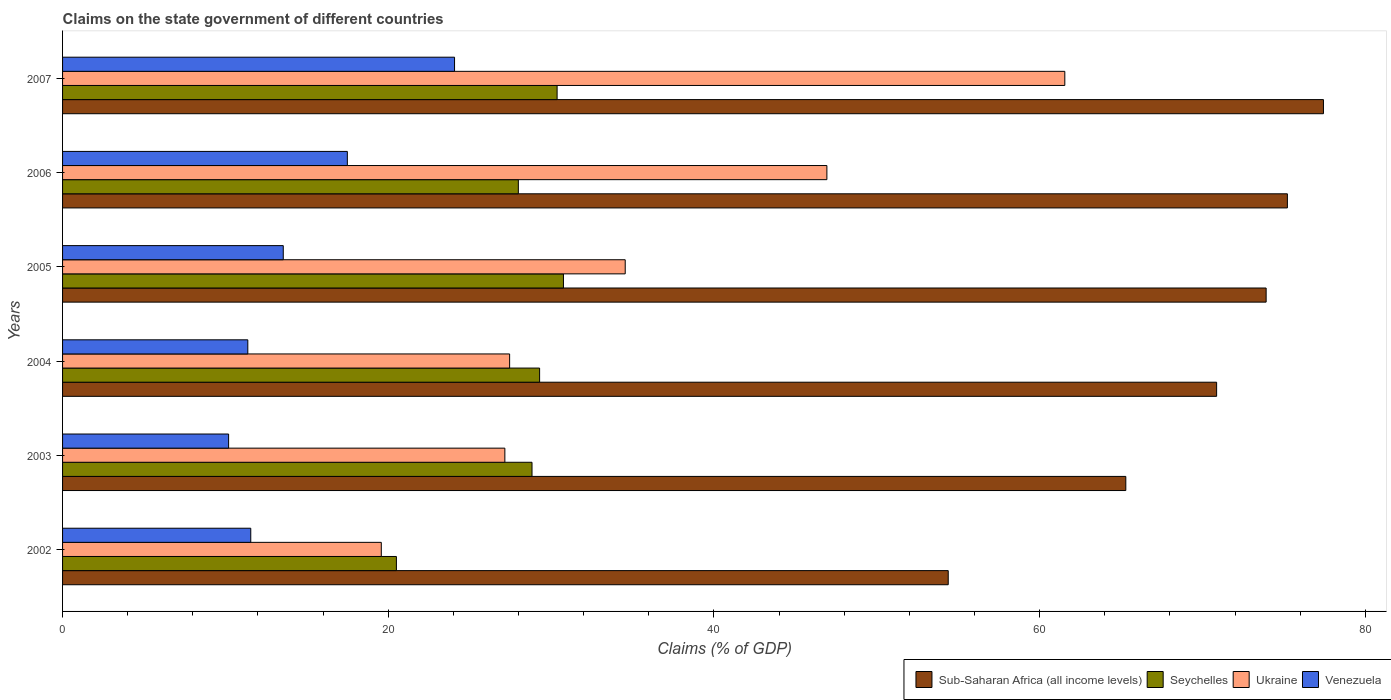How many groups of bars are there?
Ensure brevity in your answer.  6. Are the number of bars per tick equal to the number of legend labels?
Your answer should be compact. Yes. Are the number of bars on each tick of the Y-axis equal?
Give a very brief answer. Yes. How many bars are there on the 2nd tick from the top?
Give a very brief answer. 4. What is the percentage of GDP claimed on the state government in Ukraine in 2003?
Offer a terse response. 27.16. Across all years, what is the maximum percentage of GDP claimed on the state government in Ukraine?
Offer a terse response. 61.54. Across all years, what is the minimum percentage of GDP claimed on the state government in Seychelles?
Provide a short and direct response. 20.5. In which year was the percentage of GDP claimed on the state government in Ukraine maximum?
Keep it short and to the point. 2007. What is the total percentage of GDP claimed on the state government in Sub-Saharan Africa (all income levels) in the graph?
Your answer should be very brief. 417.08. What is the difference between the percentage of GDP claimed on the state government in Ukraine in 2004 and that in 2005?
Provide a short and direct response. -7.1. What is the difference between the percentage of GDP claimed on the state government in Venezuela in 2004 and the percentage of GDP claimed on the state government in Seychelles in 2007?
Your response must be concise. -18.99. What is the average percentage of GDP claimed on the state government in Ukraine per year?
Offer a very short reply. 36.2. In the year 2007, what is the difference between the percentage of GDP claimed on the state government in Sub-Saharan Africa (all income levels) and percentage of GDP claimed on the state government in Seychelles?
Ensure brevity in your answer.  47.06. In how many years, is the percentage of GDP claimed on the state government in Sub-Saharan Africa (all income levels) greater than 8 %?
Offer a terse response. 6. What is the ratio of the percentage of GDP claimed on the state government in Ukraine in 2003 to that in 2006?
Provide a succinct answer. 0.58. What is the difference between the highest and the second highest percentage of GDP claimed on the state government in Ukraine?
Offer a very short reply. 14.61. What is the difference between the highest and the lowest percentage of GDP claimed on the state government in Ukraine?
Provide a succinct answer. 41.97. In how many years, is the percentage of GDP claimed on the state government in Sub-Saharan Africa (all income levels) greater than the average percentage of GDP claimed on the state government in Sub-Saharan Africa (all income levels) taken over all years?
Offer a terse response. 4. Is the sum of the percentage of GDP claimed on the state government in Sub-Saharan Africa (all income levels) in 2005 and 2007 greater than the maximum percentage of GDP claimed on the state government in Venezuela across all years?
Provide a short and direct response. Yes. Is it the case that in every year, the sum of the percentage of GDP claimed on the state government in Seychelles and percentage of GDP claimed on the state government in Sub-Saharan Africa (all income levels) is greater than the sum of percentage of GDP claimed on the state government in Ukraine and percentage of GDP claimed on the state government in Venezuela?
Give a very brief answer. Yes. What does the 2nd bar from the top in 2004 represents?
Give a very brief answer. Ukraine. What does the 4th bar from the bottom in 2006 represents?
Your response must be concise. Venezuela. How many years are there in the graph?
Your answer should be very brief. 6. Does the graph contain grids?
Your answer should be compact. No. Where does the legend appear in the graph?
Your answer should be very brief. Bottom right. How are the legend labels stacked?
Provide a short and direct response. Horizontal. What is the title of the graph?
Give a very brief answer. Claims on the state government of different countries. Does "OECD members" appear as one of the legend labels in the graph?
Keep it short and to the point. No. What is the label or title of the X-axis?
Your answer should be compact. Claims (% of GDP). What is the Claims (% of GDP) in Sub-Saharan Africa (all income levels) in 2002?
Provide a succinct answer. 54.38. What is the Claims (% of GDP) in Seychelles in 2002?
Ensure brevity in your answer.  20.5. What is the Claims (% of GDP) in Ukraine in 2002?
Make the answer very short. 19.57. What is the Claims (% of GDP) in Venezuela in 2002?
Keep it short and to the point. 11.56. What is the Claims (% of GDP) in Sub-Saharan Africa (all income levels) in 2003?
Offer a very short reply. 65.29. What is the Claims (% of GDP) in Seychelles in 2003?
Ensure brevity in your answer.  28.83. What is the Claims (% of GDP) of Ukraine in 2003?
Offer a terse response. 27.16. What is the Claims (% of GDP) in Venezuela in 2003?
Your answer should be very brief. 10.2. What is the Claims (% of GDP) of Sub-Saharan Africa (all income levels) in 2004?
Your answer should be compact. 70.86. What is the Claims (% of GDP) of Seychelles in 2004?
Keep it short and to the point. 29.29. What is the Claims (% of GDP) in Ukraine in 2004?
Your answer should be very brief. 27.45. What is the Claims (% of GDP) in Venezuela in 2004?
Offer a terse response. 11.38. What is the Claims (% of GDP) in Sub-Saharan Africa (all income levels) in 2005?
Keep it short and to the point. 73.91. What is the Claims (% of GDP) of Seychelles in 2005?
Offer a very short reply. 30.76. What is the Claims (% of GDP) of Ukraine in 2005?
Ensure brevity in your answer.  34.55. What is the Claims (% of GDP) in Venezuela in 2005?
Your answer should be compact. 13.55. What is the Claims (% of GDP) of Sub-Saharan Africa (all income levels) in 2006?
Your answer should be very brief. 75.21. What is the Claims (% of GDP) in Seychelles in 2006?
Provide a short and direct response. 27.99. What is the Claims (% of GDP) in Ukraine in 2006?
Ensure brevity in your answer.  46.93. What is the Claims (% of GDP) in Venezuela in 2006?
Your response must be concise. 17.49. What is the Claims (% of GDP) in Sub-Saharan Africa (all income levels) in 2007?
Make the answer very short. 77.42. What is the Claims (% of GDP) of Seychelles in 2007?
Provide a succinct answer. 30.37. What is the Claims (% of GDP) in Ukraine in 2007?
Keep it short and to the point. 61.54. What is the Claims (% of GDP) in Venezuela in 2007?
Your answer should be very brief. 24.07. Across all years, what is the maximum Claims (% of GDP) of Sub-Saharan Africa (all income levels)?
Give a very brief answer. 77.42. Across all years, what is the maximum Claims (% of GDP) in Seychelles?
Your answer should be compact. 30.76. Across all years, what is the maximum Claims (% of GDP) of Ukraine?
Provide a succinct answer. 61.54. Across all years, what is the maximum Claims (% of GDP) in Venezuela?
Ensure brevity in your answer.  24.07. Across all years, what is the minimum Claims (% of GDP) in Sub-Saharan Africa (all income levels)?
Give a very brief answer. 54.38. Across all years, what is the minimum Claims (% of GDP) of Seychelles?
Ensure brevity in your answer.  20.5. Across all years, what is the minimum Claims (% of GDP) of Ukraine?
Make the answer very short. 19.57. Across all years, what is the minimum Claims (% of GDP) in Venezuela?
Offer a very short reply. 10.2. What is the total Claims (% of GDP) of Sub-Saharan Africa (all income levels) in the graph?
Give a very brief answer. 417.08. What is the total Claims (% of GDP) of Seychelles in the graph?
Give a very brief answer. 167.73. What is the total Claims (% of GDP) in Ukraine in the graph?
Keep it short and to the point. 217.21. What is the total Claims (% of GDP) in Venezuela in the graph?
Provide a succinct answer. 88.24. What is the difference between the Claims (% of GDP) in Sub-Saharan Africa (all income levels) in 2002 and that in 2003?
Keep it short and to the point. -10.9. What is the difference between the Claims (% of GDP) of Seychelles in 2002 and that in 2003?
Keep it short and to the point. -8.33. What is the difference between the Claims (% of GDP) of Ukraine in 2002 and that in 2003?
Offer a very short reply. -7.59. What is the difference between the Claims (% of GDP) in Venezuela in 2002 and that in 2003?
Ensure brevity in your answer.  1.36. What is the difference between the Claims (% of GDP) of Sub-Saharan Africa (all income levels) in 2002 and that in 2004?
Keep it short and to the point. -16.48. What is the difference between the Claims (% of GDP) in Seychelles in 2002 and that in 2004?
Offer a terse response. -8.79. What is the difference between the Claims (% of GDP) in Ukraine in 2002 and that in 2004?
Give a very brief answer. -7.88. What is the difference between the Claims (% of GDP) of Venezuela in 2002 and that in 2004?
Offer a terse response. 0.18. What is the difference between the Claims (% of GDP) in Sub-Saharan Africa (all income levels) in 2002 and that in 2005?
Your answer should be compact. -19.52. What is the difference between the Claims (% of GDP) of Seychelles in 2002 and that in 2005?
Ensure brevity in your answer.  -10.26. What is the difference between the Claims (% of GDP) of Ukraine in 2002 and that in 2005?
Your response must be concise. -14.98. What is the difference between the Claims (% of GDP) in Venezuela in 2002 and that in 2005?
Ensure brevity in your answer.  -2. What is the difference between the Claims (% of GDP) in Sub-Saharan Africa (all income levels) in 2002 and that in 2006?
Make the answer very short. -20.83. What is the difference between the Claims (% of GDP) of Seychelles in 2002 and that in 2006?
Your answer should be very brief. -7.49. What is the difference between the Claims (% of GDP) in Ukraine in 2002 and that in 2006?
Provide a short and direct response. -27.36. What is the difference between the Claims (% of GDP) in Venezuela in 2002 and that in 2006?
Your answer should be very brief. -5.93. What is the difference between the Claims (% of GDP) in Sub-Saharan Africa (all income levels) in 2002 and that in 2007?
Ensure brevity in your answer.  -23.04. What is the difference between the Claims (% of GDP) of Seychelles in 2002 and that in 2007?
Keep it short and to the point. -9.87. What is the difference between the Claims (% of GDP) in Ukraine in 2002 and that in 2007?
Your answer should be very brief. -41.97. What is the difference between the Claims (% of GDP) in Venezuela in 2002 and that in 2007?
Keep it short and to the point. -12.51. What is the difference between the Claims (% of GDP) of Sub-Saharan Africa (all income levels) in 2003 and that in 2004?
Offer a very short reply. -5.58. What is the difference between the Claims (% of GDP) in Seychelles in 2003 and that in 2004?
Provide a short and direct response. -0.47. What is the difference between the Claims (% of GDP) in Ukraine in 2003 and that in 2004?
Ensure brevity in your answer.  -0.29. What is the difference between the Claims (% of GDP) in Venezuela in 2003 and that in 2004?
Your answer should be very brief. -1.18. What is the difference between the Claims (% of GDP) of Sub-Saharan Africa (all income levels) in 2003 and that in 2005?
Provide a short and direct response. -8.62. What is the difference between the Claims (% of GDP) in Seychelles in 2003 and that in 2005?
Your answer should be compact. -1.93. What is the difference between the Claims (% of GDP) in Ukraine in 2003 and that in 2005?
Make the answer very short. -7.39. What is the difference between the Claims (% of GDP) of Venezuela in 2003 and that in 2005?
Your response must be concise. -3.36. What is the difference between the Claims (% of GDP) of Sub-Saharan Africa (all income levels) in 2003 and that in 2006?
Your answer should be very brief. -9.92. What is the difference between the Claims (% of GDP) of Seychelles in 2003 and that in 2006?
Your answer should be compact. 0.84. What is the difference between the Claims (% of GDP) of Ukraine in 2003 and that in 2006?
Your response must be concise. -19.77. What is the difference between the Claims (% of GDP) in Venezuela in 2003 and that in 2006?
Your response must be concise. -7.29. What is the difference between the Claims (% of GDP) in Sub-Saharan Africa (all income levels) in 2003 and that in 2007?
Provide a succinct answer. -12.14. What is the difference between the Claims (% of GDP) of Seychelles in 2003 and that in 2007?
Provide a short and direct response. -1.54. What is the difference between the Claims (% of GDP) in Ukraine in 2003 and that in 2007?
Your answer should be very brief. -34.38. What is the difference between the Claims (% of GDP) in Venezuela in 2003 and that in 2007?
Provide a short and direct response. -13.87. What is the difference between the Claims (% of GDP) of Sub-Saharan Africa (all income levels) in 2004 and that in 2005?
Give a very brief answer. -3.04. What is the difference between the Claims (% of GDP) in Seychelles in 2004 and that in 2005?
Provide a succinct answer. -1.46. What is the difference between the Claims (% of GDP) of Ukraine in 2004 and that in 2005?
Provide a short and direct response. -7.1. What is the difference between the Claims (% of GDP) in Venezuela in 2004 and that in 2005?
Ensure brevity in your answer.  -2.18. What is the difference between the Claims (% of GDP) in Sub-Saharan Africa (all income levels) in 2004 and that in 2006?
Provide a short and direct response. -4.35. What is the difference between the Claims (% of GDP) of Seychelles in 2004 and that in 2006?
Your answer should be very brief. 1.31. What is the difference between the Claims (% of GDP) of Ukraine in 2004 and that in 2006?
Ensure brevity in your answer.  -19.48. What is the difference between the Claims (% of GDP) in Venezuela in 2004 and that in 2006?
Ensure brevity in your answer.  -6.11. What is the difference between the Claims (% of GDP) in Sub-Saharan Africa (all income levels) in 2004 and that in 2007?
Provide a short and direct response. -6.56. What is the difference between the Claims (% of GDP) of Seychelles in 2004 and that in 2007?
Your response must be concise. -1.07. What is the difference between the Claims (% of GDP) in Ukraine in 2004 and that in 2007?
Give a very brief answer. -34.09. What is the difference between the Claims (% of GDP) in Venezuela in 2004 and that in 2007?
Ensure brevity in your answer.  -12.69. What is the difference between the Claims (% of GDP) in Sub-Saharan Africa (all income levels) in 2005 and that in 2006?
Your response must be concise. -1.31. What is the difference between the Claims (% of GDP) in Seychelles in 2005 and that in 2006?
Offer a very short reply. 2.77. What is the difference between the Claims (% of GDP) in Ukraine in 2005 and that in 2006?
Offer a terse response. -12.38. What is the difference between the Claims (% of GDP) in Venezuela in 2005 and that in 2006?
Your answer should be compact. -3.93. What is the difference between the Claims (% of GDP) in Sub-Saharan Africa (all income levels) in 2005 and that in 2007?
Provide a short and direct response. -3.52. What is the difference between the Claims (% of GDP) in Seychelles in 2005 and that in 2007?
Offer a terse response. 0.39. What is the difference between the Claims (% of GDP) of Ukraine in 2005 and that in 2007?
Offer a very short reply. -26.99. What is the difference between the Claims (% of GDP) in Venezuela in 2005 and that in 2007?
Keep it short and to the point. -10.52. What is the difference between the Claims (% of GDP) of Sub-Saharan Africa (all income levels) in 2006 and that in 2007?
Your answer should be very brief. -2.21. What is the difference between the Claims (% of GDP) of Seychelles in 2006 and that in 2007?
Provide a short and direct response. -2.38. What is the difference between the Claims (% of GDP) in Ukraine in 2006 and that in 2007?
Provide a succinct answer. -14.61. What is the difference between the Claims (% of GDP) of Venezuela in 2006 and that in 2007?
Provide a short and direct response. -6.58. What is the difference between the Claims (% of GDP) of Sub-Saharan Africa (all income levels) in 2002 and the Claims (% of GDP) of Seychelles in 2003?
Ensure brevity in your answer.  25.56. What is the difference between the Claims (% of GDP) in Sub-Saharan Africa (all income levels) in 2002 and the Claims (% of GDP) in Ukraine in 2003?
Your answer should be compact. 27.23. What is the difference between the Claims (% of GDP) in Sub-Saharan Africa (all income levels) in 2002 and the Claims (% of GDP) in Venezuela in 2003?
Provide a succinct answer. 44.19. What is the difference between the Claims (% of GDP) of Seychelles in 2002 and the Claims (% of GDP) of Ukraine in 2003?
Keep it short and to the point. -6.66. What is the difference between the Claims (% of GDP) in Seychelles in 2002 and the Claims (% of GDP) in Venezuela in 2003?
Ensure brevity in your answer.  10.3. What is the difference between the Claims (% of GDP) in Ukraine in 2002 and the Claims (% of GDP) in Venezuela in 2003?
Give a very brief answer. 9.38. What is the difference between the Claims (% of GDP) in Sub-Saharan Africa (all income levels) in 2002 and the Claims (% of GDP) in Seychelles in 2004?
Provide a succinct answer. 25.09. What is the difference between the Claims (% of GDP) in Sub-Saharan Africa (all income levels) in 2002 and the Claims (% of GDP) in Ukraine in 2004?
Keep it short and to the point. 26.93. What is the difference between the Claims (% of GDP) in Sub-Saharan Africa (all income levels) in 2002 and the Claims (% of GDP) in Venezuela in 2004?
Ensure brevity in your answer.  43.01. What is the difference between the Claims (% of GDP) in Seychelles in 2002 and the Claims (% of GDP) in Ukraine in 2004?
Give a very brief answer. -6.95. What is the difference between the Claims (% of GDP) in Seychelles in 2002 and the Claims (% of GDP) in Venezuela in 2004?
Offer a terse response. 9.12. What is the difference between the Claims (% of GDP) of Ukraine in 2002 and the Claims (% of GDP) of Venezuela in 2004?
Provide a short and direct response. 8.2. What is the difference between the Claims (% of GDP) in Sub-Saharan Africa (all income levels) in 2002 and the Claims (% of GDP) in Seychelles in 2005?
Provide a short and direct response. 23.63. What is the difference between the Claims (% of GDP) in Sub-Saharan Africa (all income levels) in 2002 and the Claims (% of GDP) in Ukraine in 2005?
Offer a terse response. 19.83. What is the difference between the Claims (% of GDP) in Sub-Saharan Africa (all income levels) in 2002 and the Claims (% of GDP) in Venezuela in 2005?
Your response must be concise. 40.83. What is the difference between the Claims (% of GDP) in Seychelles in 2002 and the Claims (% of GDP) in Ukraine in 2005?
Your response must be concise. -14.05. What is the difference between the Claims (% of GDP) of Seychelles in 2002 and the Claims (% of GDP) of Venezuela in 2005?
Ensure brevity in your answer.  6.95. What is the difference between the Claims (% of GDP) in Ukraine in 2002 and the Claims (% of GDP) in Venezuela in 2005?
Ensure brevity in your answer.  6.02. What is the difference between the Claims (% of GDP) in Sub-Saharan Africa (all income levels) in 2002 and the Claims (% of GDP) in Seychelles in 2006?
Your response must be concise. 26.4. What is the difference between the Claims (% of GDP) of Sub-Saharan Africa (all income levels) in 2002 and the Claims (% of GDP) of Ukraine in 2006?
Your response must be concise. 7.45. What is the difference between the Claims (% of GDP) in Sub-Saharan Africa (all income levels) in 2002 and the Claims (% of GDP) in Venezuela in 2006?
Offer a terse response. 36.9. What is the difference between the Claims (% of GDP) in Seychelles in 2002 and the Claims (% of GDP) in Ukraine in 2006?
Offer a very short reply. -26.43. What is the difference between the Claims (% of GDP) in Seychelles in 2002 and the Claims (% of GDP) in Venezuela in 2006?
Give a very brief answer. 3.01. What is the difference between the Claims (% of GDP) of Ukraine in 2002 and the Claims (% of GDP) of Venezuela in 2006?
Your answer should be very brief. 2.08. What is the difference between the Claims (% of GDP) of Sub-Saharan Africa (all income levels) in 2002 and the Claims (% of GDP) of Seychelles in 2007?
Provide a short and direct response. 24.02. What is the difference between the Claims (% of GDP) of Sub-Saharan Africa (all income levels) in 2002 and the Claims (% of GDP) of Ukraine in 2007?
Provide a short and direct response. -7.16. What is the difference between the Claims (% of GDP) of Sub-Saharan Africa (all income levels) in 2002 and the Claims (% of GDP) of Venezuela in 2007?
Your answer should be very brief. 30.31. What is the difference between the Claims (% of GDP) in Seychelles in 2002 and the Claims (% of GDP) in Ukraine in 2007?
Your answer should be very brief. -41.04. What is the difference between the Claims (% of GDP) of Seychelles in 2002 and the Claims (% of GDP) of Venezuela in 2007?
Offer a very short reply. -3.57. What is the difference between the Claims (% of GDP) in Ukraine in 2002 and the Claims (% of GDP) in Venezuela in 2007?
Provide a short and direct response. -4.5. What is the difference between the Claims (% of GDP) of Sub-Saharan Africa (all income levels) in 2003 and the Claims (% of GDP) of Seychelles in 2004?
Offer a very short reply. 36. What is the difference between the Claims (% of GDP) of Sub-Saharan Africa (all income levels) in 2003 and the Claims (% of GDP) of Ukraine in 2004?
Offer a terse response. 37.84. What is the difference between the Claims (% of GDP) in Sub-Saharan Africa (all income levels) in 2003 and the Claims (% of GDP) in Venezuela in 2004?
Offer a very short reply. 53.91. What is the difference between the Claims (% of GDP) in Seychelles in 2003 and the Claims (% of GDP) in Ukraine in 2004?
Your answer should be compact. 1.37. What is the difference between the Claims (% of GDP) in Seychelles in 2003 and the Claims (% of GDP) in Venezuela in 2004?
Your answer should be very brief. 17.45. What is the difference between the Claims (% of GDP) of Ukraine in 2003 and the Claims (% of GDP) of Venezuela in 2004?
Provide a short and direct response. 15.78. What is the difference between the Claims (% of GDP) in Sub-Saharan Africa (all income levels) in 2003 and the Claims (% of GDP) in Seychelles in 2005?
Offer a terse response. 34.53. What is the difference between the Claims (% of GDP) in Sub-Saharan Africa (all income levels) in 2003 and the Claims (% of GDP) in Ukraine in 2005?
Your answer should be very brief. 30.74. What is the difference between the Claims (% of GDP) of Sub-Saharan Africa (all income levels) in 2003 and the Claims (% of GDP) of Venezuela in 2005?
Provide a short and direct response. 51.74. What is the difference between the Claims (% of GDP) in Seychelles in 2003 and the Claims (% of GDP) in Ukraine in 2005?
Offer a terse response. -5.72. What is the difference between the Claims (% of GDP) of Seychelles in 2003 and the Claims (% of GDP) of Venezuela in 2005?
Keep it short and to the point. 15.27. What is the difference between the Claims (% of GDP) in Ukraine in 2003 and the Claims (% of GDP) in Venezuela in 2005?
Offer a very short reply. 13.61. What is the difference between the Claims (% of GDP) of Sub-Saharan Africa (all income levels) in 2003 and the Claims (% of GDP) of Seychelles in 2006?
Offer a terse response. 37.3. What is the difference between the Claims (% of GDP) of Sub-Saharan Africa (all income levels) in 2003 and the Claims (% of GDP) of Ukraine in 2006?
Your response must be concise. 18.36. What is the difference between the Claims (% of GDP) in Sub-Saharan Africa (all income levels) in 2003 and the Claims (% of GDP) in Venezuela in 2006?
Give a very brief answer. 47.8. What is the difference between the Claims (% of GDP) of Seychelles in 2003 and the Claims (% of GDP) of Ukraine in 2006?
Make the answer very short. -18.11. What is the difference between the Claims (% of GDP) in Seychelles in 2003 and the Claims (% of GDP) in Venezuela in 2006?
Your answer should be very brief. 11.34. What is the difference between the Claims (% of GDP) of Ukraine in 2003 and the Claims (% of GDP) of Venezuela in 2006?
Make the answer very short. 9.67. What is the difference between the Claims (% of GDP) in Sub-Saharan Africa (all income levels) in 2003 and the Claims (% of GDP) in Seychelles in 2007?
Make the answer very short. 34.92. What is the difference between the Claims (% of GDP) in Sub-Saharan Africa (all income levels) in 2003 and the Claims (% of GDP) in Ukraine in 2007?
Keep it short and to the point. 3.75. What is the difference between the Claims (% of GDP) in Sub-Saharan Africa (all income levels) in 2003 and the Claims (% of GDP) in Venezuela in 2007?
Your answer should be compact. 41.22. What is the difference between the Claims (% of GDP) in Seychelles in 2003 and the Claims (% of GDP) in Ukraine in 2007?
Your response must be concise. -32.72. What is the difference between the Claims (% of GDP) in Seychelles in 2003 and the Claims (% of GDP) in Venezuela in 2007?
Keep it short and to the point. 4.76. What is the difference between the Claims (% of GDP) in Ukraine in 2003 and the Claims (% of GDP) in Venezuela in 2007?
Your answer should be very brief. 3.09. What is the difference between the Claims (% of GDP) of Sub-Saharan Africa (all income levels) in 2004 and the Claims (% of GDP) of Seychelles in 2005?
Offer a terse response. 40.11. What is the difference between the Claims (% of GDP) in Sub-Saharan Africa (all income levels) in 2004 and the Claims (% of GDP) in Ukraine in 2005?
Make the answer very short. 36.31. What is the difference between the Claims (% of GDP) in Sub-Saharan Africa (all income levels) in 2004 and the Claims (% of GDP) in Venezuela in 2005?
Provide a short and direct response. 57.31. What is the difference between the Claims (% of GDP) of Seychelles in 2004 and the Claims (% of GDP) of Ukraine in 2005?
Provide a short and direct response. -5.26. What is the difference between the Claims (% of GDP) of Seychelles in 2004 and the Claims (% of GDP) of Venezuela in 2005?
Provide a short and direct response. 15.74. What is the difference between the Claims (% of GDP) of Ukraine in 2004 and the Claims (% of GDP) of Venezuela in 2005?
Your response must be concise. 13.9. What is the difference between the Claims (% of GDP) in Sub-Saharan Africa (all income levels) in 2004 and the Claims (% of GDP) in Seychelles in 2006?
Your answer should be very brief. 42.88. What is the difference between the Claims (% of GDP) in Sub-Saharan Africa (all income levels) in 2004 and the Claims (% of GDP) in Ukraine in 2006?
Offer a very short reply. 23.93. What is the difference between the Claims (% of GDP) of Sub-Saharan Africa (all income levels) in 2004 and the Claims (% of GDP) of Venezuela in 2006?
Ensure brevity in your answer.  53.38. What is the difference between the Claims (% of GDP) of Seychelles in 2004 and the Claims (% of GDP) of Ukraine in 2006?
Provide a short and direct response. -17.64. What is the difference between the Claims (% of GDP) of Seychelles in 2004 and the Claims (% of GDP) of Venezuela in 2006?
Your response must be concise. 11.81. What is the difference between the Claims (% of GDP) of Ukraine in 2004 and the Claims (% of GDP) of Venezuela in 2006?
Offer a very short reply. 9.96. What is the difference between the Claims (% of GDP) in Sub-Saharan Africa (all income levels) in 2004 and the Claims (% of GDP) in Seychelles in 2007?
Give a very brief answer. 40.5. What is the difference between the Claims (% of GDP) of Sub-Saharan Africa (all income levels) in 2004 and the Claims (% of GDP) of Ukraine in 2007?
Offer a terse response. 9.32. What is the difference between the Claims (% of GDP) of Sub-Saharan Africa (all income levels) in 2004 and the Claims (% of GDP) of Venezuela in 2007?
Provide a succinct answer. 46.79. What is the difference between the Claims (% of GDP) in Seychelles in 2004 and the Claims (% of GDP) in Ukraine in 2007?
Give a very brief answer. -32.25. What is the difference between the Claims (% of GDP) in Seychelles in 2004 and the Claims (% of GDP) in Venezuela in 2007?
Your response must be concise. 5.22. What is the difference between the Claims (% of GDP) of Ukraine in 2004 and the Claims (% of GDP) of Venezuela in 2007?
Your answer should be very brief. 3.38. What is the difference between the Claims (% of GDP) of Sub-Saharan Africa (all income levels) in 2005 and the Claims (% of GDP) of Seychelles in 2006?
Give a very brief answer. 45.92. What is the difference between the Claims (% of GDP) in Sub-Saharan Africa (all income levels) in 2005 and the Claims (% of GDP) in Ukraine in 2006?
Make the answer very short. 26.97. What is the difference between the Claims (% of GDP) of Sub-Saharan Africa (all income levels) in 2005 and the Claims (% of GDP) of Venezuela in 2006?
Keep it short and to the point. 56.42. What is the difference between the Claims (% of GDP) in Seychelles in 2005 and the Claims (% of GDP) in Ukraine in 2006?
Keep it short and to the point. -16.18. What is the difference between the Claims (% of GDP) in Seychelles in 2005 and the Claims (% of GDP) in Venezuela in 2006?
Give a very brief answer. 13.27. What is the difference between the Claims (% of GDP) of Ukraine in 2005 and the Claims (% of GDP) of Venezuela in 2006?
Your answer should be very brief. 17.06. What is the difference between the Claims (% of GDP) in Sub-Saharan Africa (all income levels) in 2005 and the Claims (% of GDP) in Seychelles in 2007?
Your answer should be very brief. 43.54. What is the difference between the Claims (% of GDP) in Sub-Saharan Africa (all income levels) in 2005 and the Claims (% of GDP) in Ukraine in 2007?
Your response must be concise. 12.36. What is the difference between the Claims (% of GDP) of Sub-Saharan Africa (all income levels) in 2005 and the Claims (% of GDP) of Venezuela in 2007?
Your answer should be very brief. 49.84. What is the difference between the Claims (% of GDP) in Seychelles in 2005 and the Claims (% of GDP) in Ukraine in 2007?
Give a very brief answer. -30.79. What is the difference between the Claims (% of GDP) in Seychelles in 2005 and the Claims (% of GDP) in Venezuela in 2007?
Your response must be concise. 6.69. What is the difference between the Claims (% of GDP) of Ukraine in 2005 and the Claims (% of GDP) of Venezuela in 2007?
Your answer should be very brief. 10.48. What is the difference between the Claims (% of GDP) in Sub-Saharan Africa (all income levels) in 2006 and the Claims (% of GDP) in Seychelles in 2007?
Keep it short and to the point. 44.84. What is the difference between the Claims (% of GDP) of Sub-Saharan Africa (all income levels) in 2006 and the Claims (% of GDP) of Ukraine in 2007?
Ensure brevity in your answer.  13.67. What is the difference between the Claims (% of GDP) of Sub-Saharan Africa (all income levels) in 2006 and the Claims (% of GDP) of Venezuela in 2007?
Ensure brevity in your answer.  51.14. What is the difference between the Claims (% of GDP) in Seychelles in 2006 and the Claims (% of GDP) in Ukraine in 2007?
Offer a terse response. -33.56. What is the difference between the Claims (% of GDP) of Seychelles in 2006 and the Claims (% of GDP) of Venezuela in 2007?
Make the answer very short. 3.92. What is the difference between the Claims (% of GDP) in Ukraine in 2006 and the Claims (% of GDP) in Venezuela in 2007?
Give a very brief answer. 22.86. What is the average Claims (% of GDP) in Sub-Saharan Africa (all income levels) per year?
Make the answer very short. 69.51. What is the average Claims (% of GDP) of Seychelles per year?
Offer a very short reply. 27.95. What is the average Claims (% of GDP) of Ukraine per year?
Give a very brief answer. 36.2. What is the average Claims (% of GDP) in Venezuela per year?
Keep it short and to the point. 14.71. In the year 2002, what is the difference between the Claims (% of GDP) of Sub-Saharan Africa (all income levels) and Claims (% of GDP) of Seychelles?
Make the answer very short. 33.89. In the year 2002, what is the difference between the Claims (% of GDP) in Sub-Saharan Africa (all income levels) and Claims (% of GDP) in Ukraine?
Your answer should be very brief. 34.81. In the year 2002, what is the difference between the Claims (% of GDP) in Sub-Saharan Africa (all income levels) and Claims (% of GDP) in Venezuela?
Offer a very short reply. 42.83. In the year 2002, what is the difference between the Claims (% of GDP) in Seychelles and Claims (% of GDP) in Ukraine?
Provide a short and direct response. 0.93. In the year 2002, what is the difference between the Claims (% of GDP) of Seychelles and Claims (% of GDP) of Venezuela?
Ensure brevity in your answer.  8.94. In the year 2002, what is the difference between the Claims (% of GDP) in Ukraine and Claims (% of GDP) in Venezuela?
Provide a short and direct response. 8.02. In the year 2003, what is the difference between the Claims (% of GDP) in Sub-Saharan Africa (all income levels) and Claims (% of GDP) in Seychelles?
Offer a very short reply. 36.46. In the year 2003, what is the difference between the Claims (% of GDP) of Sub-Saharan Africa (all income levels) and Claims (% of GDP) of Ukraine?
Provide a succinct answer. 38.13. In the year 2003, what is the difference between the Claims (% of GDP) in Sub-Saharan Africa (all income levels) and Claims (% of GDP) in Venezuela?
Make the answer very short. 55.09. In the year 2003, what is the difference between the Claims (% of GDP) in Seychelles and Claims (% of GDP) in Ukraine?
Provide a short and direct response. 1.67. In the year 2003, what is the difference between the Claims (% of GDP) in Seychelles and Claims (% of GDP) in Venezuela?
Ensure brevity in your answer.  18.63. In the year 2003, what is the difference between the Claims (% of GDP) of Ukraine and Claims (% of GDP) of Venezuela?
Ensure brevity in your answer.  16.96. In the year 2004, what is the difference between the Claims (% of GDP) in Sub-Saharan Africa (all income levels) and Claims (% of GDP) in Seychelles?
Provide a short and direct response. 41.57. In the year 2004, what is the difference between the Claims (% of GDP) in Sub-Saharan Africa (all income levels) and Claims (% of GDP) in Ukraine?
Make the answer very short. 43.41. In the year 2004, what is the difference between the Claims (% of GDP) in Sub-Saharan Africa (all income levels) and Claims (% of GDP) in Venezuela?
Offer a terse response. 59.49. In the year 2004, what is the difference between the Claims (% of GDP) of Seychelles and Claims (% of GDP) of Ukraine?
Give a very brief answer. 1.84. In the year 2004, what is the difference between the Claims (% of GDP) in Seychelles and Claims (% of GDP) in Venezuela?
Provide a succinct answer. 17.92. In the year 2004, what is the difference between the Claims (% of GDP) of Ukraine and Claims (% of GDP) of Venezuela?
Offer a very short reply. 16.08. In the year 2005, what is the difference between the Claims (% of GDP) in Sub-Saharan Africa (all income levels) and Claims (% of GDP) in Seychelles?
Ensure brevity in your answer.  43.15. In the year 2005, what is the difference between the Claims (% of GDP) in Sub-Saharan Africa (all income levels) and Claims (% of GDP) in Ukraine?
Ensure brevity in your answer.  39.36. In the year 2005, what is the difference between the Claims (% of GDP) of Sub-Saharan Africa (all income levels) and Claims (% of GDP) of Venezuela?
Provide a succinct answer. 60.35. In the year 2005, what is the difference between the Claims (% of GDP) of Seychelles and Claims (% of GDP) of Ukraine?
Ensure brevity in your answer.  -3.79. In the year 2005, what is the difference between the Claims (% of GDP) in Seychelles and Claims (% of GDP) in Venezuela?
Keep it short and to the point. 17.21. In the year 2005, what is the difference between the Claims (% of GDP) of Ukraine and Claims (% of GDP) of Venezuela?
Make the answer very short. 21. In the year 2006, what is the difference between the Claims (% of GDP) of Sub-Saharan Africa (all income levels) and Claims (% of GDP) of Seychelles?
Make the answer very short. 47.22. In the year 2006, what is the difference between the Claims (% of GDP) in Sub-Saharan Africa (all income levels) and Claims (% of GDP) in Ukraine?
Provide a succinct answer. 28.28. In the year 2006, what is the difference between the Claims (% of GDP) of Sub-Saharan Africa (all income levels) and Claims (% of GDP) of Venezuela?
Give a very brief answer. 57.72. In the year 2006, what is the difference between the Claims (% of GDP) of Seychelles and Claims (% of GDP) of Ukraine?
Your answer should be compact. -18.95. In the year 2006, what is the difference between the Claims (% of GDP) in Seychelles and Claims (% of GDP) in Venezuela?
Your answer should be compact. 10.5. In the year 2006, what is the difference between the Claims (% of GDP) of Ukraine and Claims (% of GDP) of Venezuela?
Keep it short and to the point. 29.45. In the year 2007, what is the difference between the Claims (% of GDP) of Sub-Saharan Africa (all income levels) and Claims (% of GDP) of Seychelles?
Provide a succinct answer. 47.06. In the year 2007, what is the difference between the Claims (% of GDP) in Sub-Saharan Africa (all income levels) and Claims (% of GDP) in Ukraine?
Your answer should be very brief. 15.88. In the year 2007, what is the difference between the Claims (% of GDP) in Sub-Saharan Africa (all income levels) and Claims (% of GDP) in Venezuela?
Your answer should be very brief. 53.35. In the year 2007, what is the difference between the Claims (% of GDP) of Seychelles and Claims (% of GDP) of Ukraine?
Make the answer very short. -31.18. In the year 2007, what is the difference between the Claims (% of GDP) in Seychelles and Claims (% of GDP) in Venezuela?
Make the answer very short. 6.3. In the year 2007, what is the difference between the Claims (% of GDP) of Ukraine and Claims (% of GDP) of Venezuela?
Your response must be concise. 37.47. What is the ratio of the Claims (% of GDP) of Sub-Saharan Africa (all income levels) in 2002 to that in 2003?
Your answer should be very brief. 0.83. What is the ratio of the Claims (% of GDP) in Seychelles in 2002 to that in 2003?
Ensure brevity in your answer.  0.71. What is the ratio of the Claims (% of GDP) in Ukraine in 2002 to that in 2003?
Offer a very short reply. 0.72. What is the ratio of the Claims (% of GDP) in Venezuela in 2002 to that in 2003?
Provide a succinct answer. 1.13. What is the ratio of the Claims (% of GDP) of Sub-Saharan Africa (all income levels) in 2002 to that in 2004?
Provide a short and direct response. 0.77. What is the ratio of the Claims (% of GDP) of Seychelles in 2002 to that in 2004?
Your answer should be very brief. 0.7. What is the ratio of the Claims (% of GDP) in Ukraine in 2002 to that in 2004?
Your response must be concise. 0.71. What is the ratio of the Claims (% of GDP) in Venezuela in 2002 to that in 2004?
Ensure brevity in your answer.  1.02. What is the ratio of the Claims (% of GDP) in Sub-Saharan Africa (all income levels) in 2002 to that in 2005?
Offer a terse response. 0.74. What is the ratio of the Claims (% of GDP) in Seychelles in 2002 to that in 2005?
Make the answer very short. 0.67. What is the ratio of the Claims (% of GDP) in Ukraine in 2002 to that in 2005?
Ensure brevity in your answer.  0.57. What is the ratio of the Claims (% of GDP) of Venezuela in 2002 to that in 2005?
Make the answer very short. 0.85. What is the ratio of the Claims (% of GDP) of Sub-Saharan Africa (all income levels) in 2002 to that in 2006?
Make the answer very short. 0.72. What is the ratio of the Claims (% of GDP) in Seychelles in 2002 to that in 2006?
Make the answer very short. 0.73. What is the ratio of the Claims (% of GDP) of Ukraine in 2002 to that in 2006?
Offer a terse response. 0.42. What is the ratio of the Claims (% of GDP) of Venezuela in 2002 to that in 2006?
Give a very brief answer. 0.66. What is the ratio of the Claims (% of GDP) of Sub-Saharan Africa (all income levels) in 2002 to that in 2007?
Ensure brevity in your answer.  0.7. What is the ratio of the Claims (% of GDP) of Seychelles in 2002 to that in 2007?
Offer a terse response. 0.68. What is the ratio of the Claims (% of GDP) of Ukraine in 2002 to that in 2007?
Your response must be concise. 0.32. What is the ratio of the Claims (% of GDP) of Venezuela in 2002 to that in 2007?
Your response must be concise. 0.48. What is the ratio of the Claims (% of GDP) of Sub-Saharan Africa (all income levels) in 2003 to that in 2004?
Provide a short and direct response. 0.92. What is the ratio of the Claims (% of GDP) in Seychelles in 2003 to that in 2004?
Offer a terse response. 0.98. What is the ratio of the Claims (% of GDP) in Ukraine in 2003 to that in 2004?
Offer a terse response. 0.99. What is the ratio of the Claims (% of GDP) of Venezuela in 2003 to that in 2004?
Keep it short and to the point. 0.9. What is the ratio of the Claims (% of GDP) in Sub-Saharan Africa (all income levels) in 2003 to that in 2005?
Your answer should be compact. 0.88. What is the ratio of the Claims (% of GDP) in Seychelles in 2003 to that in 2005?
Your answer should be very brief. 0.94. What is the ratio of the Claims (% of GDP) of Ukraine in 2003 to that in 2005?
Provide a short and direct response. 0.79. What is the ratio of the Claims (% of GDP) of Venezuela in 2003 to that in 2005?
Your answer should be compact. 0.75. What is the ratio of the Claims (% of GDP) in Sub-Saharan Africa (all income levels) in 2003 to that in 2006?
Give a very brief answer. 0.87. What is the ratio of the Claims (% of GDP) in Ukraine in 2003 to that in 2006?
Your response must be concise. 0.58. What is the ratio of the Claims (% of GDP) of Venezuela in 2003 to that in 2006?
Offer a very short reply. 0.58. What is the ratio of the Claims (% of GDP) of Sub-Saharan Africa (all income levels) in 2003 to that in 2007?
Keep it short and to the point. 0.84. What is the ratio of the Claims (% of GDP) of Seychelles in 2003 to that in 2007?
Make the answer very short. 0.95. What is the ratio of the Claims (% of GDP) of Ukraine in 2003 to that in 2007?
Your answer should be compact. 0.44. What is the ratio of the Claims (% of GDP) of Venezuela in 2003 to that in 2007?
Your answer should be compact. 0.42. What is the ratio of the Claims (% of GDP) of Sub-Saharan Africa (all income levels) in 2004 to that in 2005?
Ensure brevity in your answer.  0.96. What is the ratio of the Claims (% of GDP) of Seychelles in 2004 to that in 2005?
Your answer should be very brief. 0.95. What is the ratio of the Claims (% of GDP) in Ukraine in 2004 to that in 2005?
Offer a very short reply. 0.79. What is the ratio of the Claims (% of GDP) of Venezuela in 2004 to that in 2005?
Make the answer very short. 0.84. What is the ratio of the Claims (% of GDP) of Sub-Saharan Africa (all income levels) in 2004 to that in 2006?
Offer a terse response. 0.94. What is the ratio of the Claims (% of GDP) in Seychelles in 2004 to that in 2006?
Your answer should be very brief. 1.05. What is the ratio of the Claims (% of GDP) of Ukraine in 2004 to that in 2006?
Give a very brief answer. 0.58. What is the ratio of the Claims (% of GDP) of Venezuela in 2004 to that in 2006?
Offer a very short reply. 0.65. What is the ratio of the Claims (% of GDP) of Sub-Saharan Africa (all income levels) in 2004 to that in 2007?
Ensure brevity in your answer.  0.92. What is the ratio of the Claims (% of GDP) of Seychelles in 2004 to that in 2007?
Give a very brief answer. 0.96. What is the ratio of the Claims (% of GDP) of Ukraine in 2004 to that in 2007?
Make the answer very short. 0.45. What is the ratio of the Claims (% of GDP) in Venezuela in 2004 to that in 2007?
Your answer should be compact. 0.47. What is the ratio of the Claims (% of GDP) in Sub-Saharan Africa (all income levels) in 2005 to that in 2006?
Offer a terse response. 0.98. What is the ratio of the Claims (% of GDP) in Seychelles in 2005 to that in 2006?
Give a very brief answer. 1.1. What is the ratio of the Claims (% of GDP) of Ukraine in 2005 to that in 2006?
Your answer should be very brief. 0.74. What is the ratio of the Claims (% of GDP) in Venezuela in 2005 to that in 2006?
Your response must be concise. 0.78. What is the ratio of the Claims (% of GDP) in Sub-Saharan Africa (all income levels) in 2005 to that in 2007?
Keep it short and to the point. 0.95. What is the ratio of the Claims (% of GDP) in Seychelles in 2005 to that in 2007?
Offer a terse response. 1.01. What is the ratio of the Claims (% of GDP) of Ukraine in 2005 to that in 2007?
Make the answer very short. 0.56. What is the ratio of the Claims (% of GDP) in Venezuela in 2005 to that in 2007?
Your response must be concise. 0.56. What is the ratio of the Claims (% of GDP) in Sub-Saharan Africa (all income levels) in 2006 to that in 2007?
Provide a succinct answer. 0.97. What is the ratio of the Claims (% of GDP) in Seychelles in 2006 to that in 2007?
Your answer should be compact. 0.92. What is the ratio of the Claims (% of GDP) in Ukraine in 2006 to that in 2007?
Offer a terse response. 0.76. What is the ratio of the Claims (% of GDP) in Venezuela in 2006 to that in 2007?
Give a very brief answer. 0.73. What is the difference between the highest and the second highest Claims (% of GDP) in Sub-Saharan Africa (all income levels)?
Your answer should be very brief. 2.21. What is the difference between the highest and the second highest Claims (% of GDP) in Seychelles?
Offer a very short reply. 0.39. What is the difference between the highest and the second highest Claims (% of GDP) in Ukraine?
Give a very brief answer. 14.61. What is the difference between the highest and the second highest Claims (% of GDP) of Venezuela?
Your answer should be very brief. 6.58. What is the difference between the highest and the lowest Claims (% of GDP) of Sub-Saharan Africa (all income levels)?
Your answer should be very brief. 23.04. What is the difference between the highest and the lowest Claims (% of GDP) of Seychelles?
Make the answer very short. 10.26. What is the difference between the highest and the lowest Claims (% of GDP) in Ukraine?
Make the answer very short. 41.97. What is the difference between the highest and the lowest Claims (% of GDP) of Venezuela?
Provide a short and direct response. 13.87. 